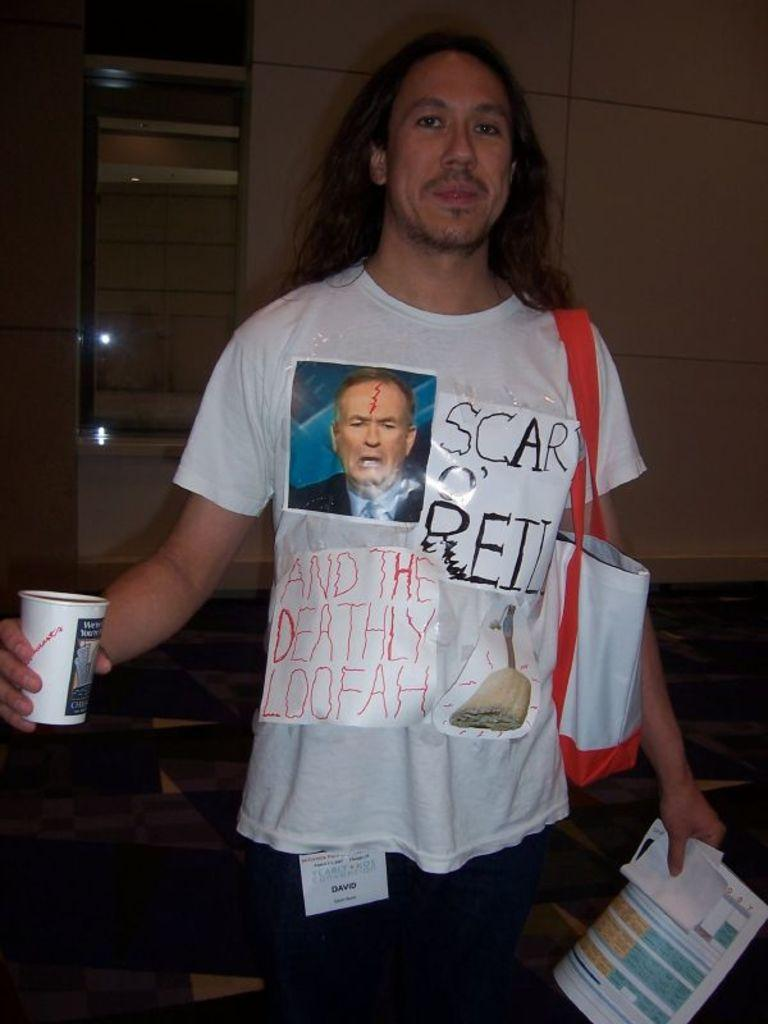<image>
Offer a succinct explanation of the picture presented. A man wears a shirt with the handwritten words "Scar O'Reilly and the Deathly Loofah" on it. 